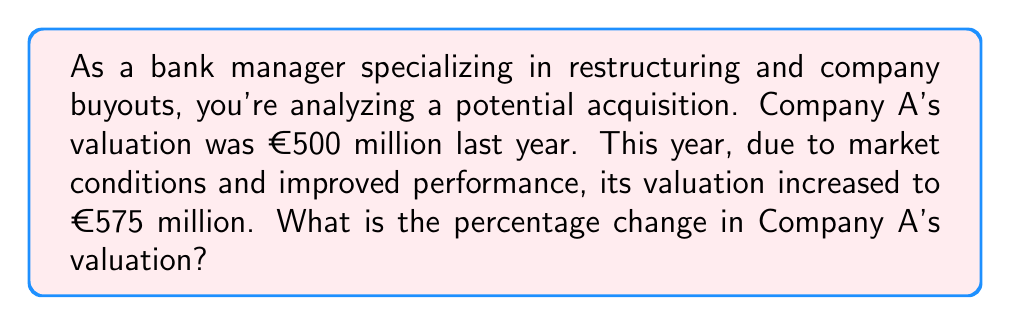Solve this math problem. To calculate the percentage change in Company A's valuation, we need to follow these steps:

1. Calculate the absolute change in valuation:
   $\text{Change} = \text{New Value} - \text{Original Value}$
   $\text{Change} = €575\text{ million} - €500\text{ million} = €75\text{ million}$

2. Calculate the percentage change using the formula:
   $$\text{Percentage Change} = \frac{\text{Change}}{\text{Original Value}} \times 100\%$$

3. Substitute the values into the formula:
   $$\text{Percentage Change} = \frac{€75\text{ million}}{€500\text{ million}} \times 100\%$$

4. Perform the division:
   $$\text{Percentage Change} = 0.15 \times 100\%$$

5. Convert the decimal to a percentage:
   $$\text{Percentage Change} = 15\%$$

Therefore, the percentage change in Company A's valuation is an increase of 15%.
Answer: 15% increase 